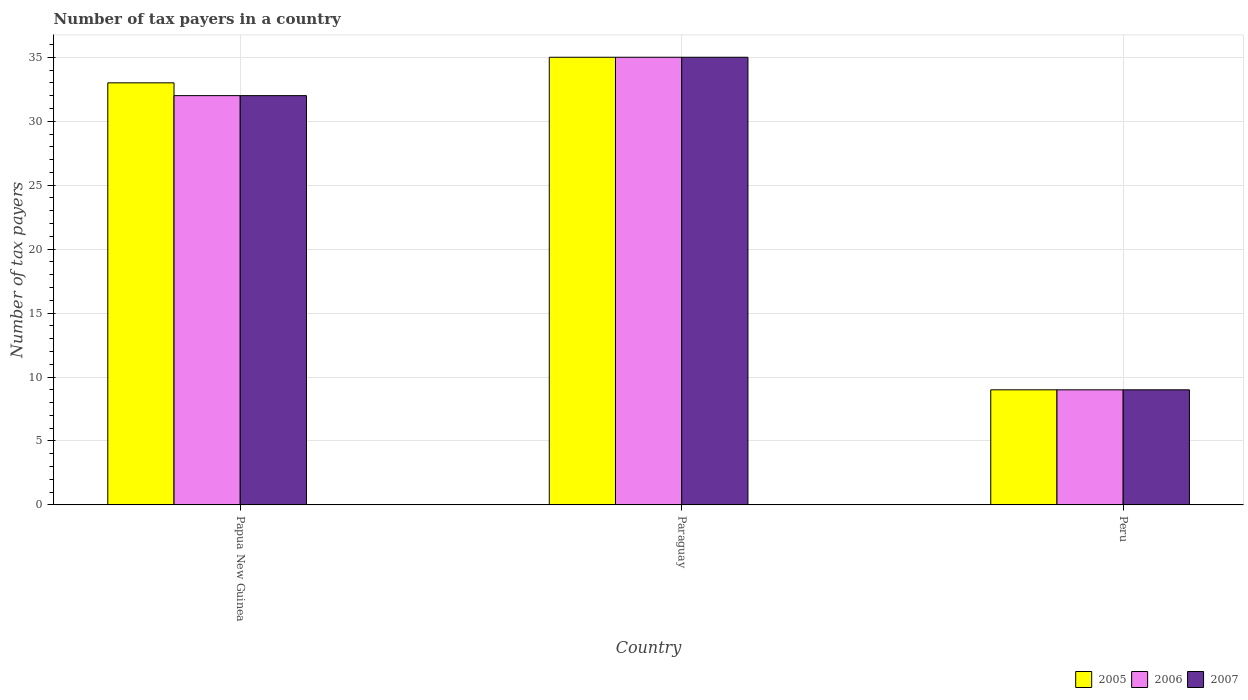How many different coloured bars are there?
Offer a very short reply. 3. Are the number of bars per tick equal to the number of legend labels?
Offer a very short reply. Yes. How many bars are there on the 2nd tick from the left?
Provide a succinct answer. 3. How many bars are there on the 2nd tick from the right?
Ensure brevity in your answer.  3. What is the label of the 1st group of bars from the left?
Give a very brief answer. Papua New Guinea. In how many cases, is the number of bars for a given country not equal to the number of legend labels?
Provide a succinct answer. 0. Across all countries, what is the maximum number of tax payers in in 2005?
Keep it short and to the point. 35. Across all countries, what is the minimum number of tax payers in in 2005?
Your answer should be very brief. 9. In which country was the number of tax payers in in 2006 maximum?
Keep it short and to the point. Paraguay. What is the total number of tax payers in in 2006 in the graph?
Offer a very short reply. 76. What is the difference between the number of tax payers in in 2007 in Papua New Guinea and that in Peru?
Provide a succinct answer. 23. What is the difference between the number of tax payers in in 2005 in Papua New Guinea and the number of tax payers in in 2006 in Peru?
Keep it short and to the point. 24. What is the average number of tax payers in in 2007 per country?
Ensure brevity in your answer.  25.33. What is the difference between the number of tax payers in of/in 2007 and number of tax payers in of/in 2006 in Peru?
Keep it short and to the point. 0. In how many countries, is the number of tax payers in in 2007 greater than 26?
Give a very brief answer. 2. What is the ratio of the number of tax payers in in 2005 in Papua New Guinea to that in Paraguay?
Ensure brevity in your answer.  0.94. Is the difference between the number of tax payers in in 2007 in Papua New Guinea and Paraguay greater than the difference between the number of tax payers in in 2006 in Papua New Guinea and Paraguay?
Provide a succinct answer. No. What is the difference between the highest and the second highest number of tax payers in in 2005?
Keep it short and to the point. -2. Is the sum of the number of tax payers in in 2005 in Papua New Guinea and Paraguay greater than the maximum number of tax payers in in 2006 across all countries?
Your answer should be very brief. Yes. Is it the case that in every country, the sum of the number of tax payers in in 2005 and number of tax payers in in 2006 is greater than the number of tax payers in in 2007?
Ensure brevity in your answer.  Yes. How many bars are there?
Offer a very short reply. 9. How many countries are there in the graph?
Your answer should be compact. 3. What is the difference between two consecutive major ticks on the Y-axis?
Your answer should be very brief. 5. Does the graph contain any zero values?
Keep it short and to the point. No. Does the graph contain grids?
Provide a succinct answer. Yes. Where does the legend appear in the graph?
Provide a succinct answer. Bottom right. How are the legend labels stacked?
Make the answer very short. Horizontal. What is the title of the graph?
Offer a very short reply. Number of tax payers in a country. Does "1961" appear as one of the legend labels in the graph?
Keep it short and to the point. No. What is the label or title of the X-axis?
Your answer should be very brief. Country. What is the label or title of the Y-axis?
Give a very brief answer. Number of tax payers. What is the Number of tax payers in 2006 in Papua New Guinea?
Give a very brief answer. 32. What is the Number of tax payers of 2005 in Paraguay?
Provide a short and direct response. 35. What is the Number of tax payers of 2006 in Paraguay?
Make the answer very short. 35. What is the Number of tax payers in 2007 in Paraguay?
Your response must be concise. 35. What is the Number of tax payers of 2007 in Peru?
Offer a very short reply. 9. Across all countries, what is the minimum Number of tax payers of 2006?
Your response must be concise. 9. Across all countries, what is the minimum Number of tax payers in 2007?
Ensure brevity in your answer.  9. What is the total Number of tax payers of 2007 in the graph?
Offer a very short reply. 76. What is the difference between the Number of tax payers of 2006 in Papua New Guinea and that in Paraguay?
Provide a short and direct response. -3. What is the difference between the Number of tax payers of 2007 in Papua New Guinea and that in Paraguay?
Make the answer very short. -3. What is the difference between the Number of tax payers of 2006 in Paraguay and that in Peru?
Give a very brief answer. 26. What is the difference between the Number of tax payers in 2006 in Papua New Guinea and the Number of tax payers in 2007 in Peru?
Provide a succinct answer. 23. What is the difference between the Number of tax payers in 2005 in Paraguay and the Number of tax payers in 2006 in Peru?
Give a very brief answer. 26. What is the difference between the Number of tax payers in 2005 in Paraguay and the Number of tax payers in 2007 in Peru?
Ensure brevity in your answer.  26. What is the average Number of tax payers in 2005 per country?
Your answer should be very brief. 25.67. What is the average Number of tax payers in 2006 per country?
Keep it short and to the point. 25.33. What is the average Number of tax payers of 2007 per country?
Offer a terse response. 25.33. What is the difference between the Number of tax payers in 2005 and Number of tax payers in 2006 in Papua New Guinea?
Ensure brevity in your answer.  1. What is the difference between the Number of tax payers in 2006 and Number of tax payers in 2007 in Papua New Guinea?
Your answer should be compact. 0. What is the difference between the Number of tax payers in 2006 and Number of tax payers in 2007 in Paraguay?
Offer a very short reply. 0. What is the difference between the Number of tax payers in 2005 and Number of tax payers in 2007 in Peru?
Your answer should be compact. 0. What is the difference between the Number of tax payers of 2006 and Number of tax payers of 2007 in Peru?
Give a very brief answer. 0. What is the ratio of the Number of tax payers in 2005 in Papua New Guinea to that in Paraguay?
Ensure brevity in your answer.  0.94. What is the ratio of the Number of tax payers of 2006 in Papua New Guinea to that in Paraguay?
Keep it short and to the point. 0.91. What is the ratio of the Number of tax payers of 2007 in Papua New Guinea to that in Paraguay?
Ensure brevity in your answer.  0.91. What is the ratio of the Number of tax payers in 2005 in Papua New Guinea to that in Peru?
Keep it short and to the point. 3.67. What is the ratio of the Number of tax payers of 2006 in Papua New Guinea to that in Peru?
Make the answer very short. 3.56. What is the ratio of the Number of tax payers in 2007 in Papua New Guinea to that in Peru?
Your response must be concise. 3.56. What is the ratio of the Number of tax payers in 2005 in Paraguay to that in Peru?
Make the answer very short. 3.89. What is the ratio of the Number of tax payers of 2006 in Paraguay to that in Peru?
Ensure brevity in your answer.  3.89. What is the ratio of the Number of tax payers of 2007 in Paraguay to that in Peru?
Offer a very short reply. 3.89. What is the difference between the highest and the second highest Number of tax payers of 2007?
Your answer should be compact. 3. 